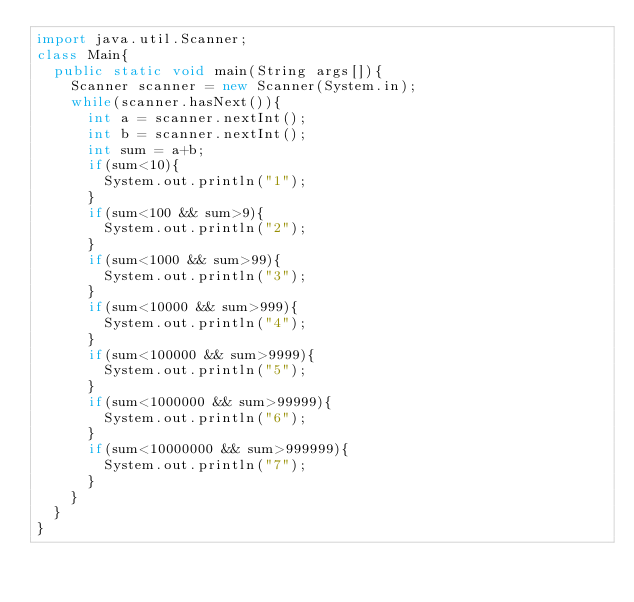Convert code to text. <code><loc_0><loc_0><loc_500><loc_500><_Java_>import java.util.Scanner;
class Main{
	public static void main(String args[]){
		Scanner scanner = new Scanner(System.in);
		while(scanner.hasNext()){	
			int a = scanner.nextInt();
			int b = scanner.nextInt();
			int sum = a+b;
			if(sum<10){
				System.out.println("1");
			}
			if(sum<100 && sum>9){
				System.out.println("2");
			}
			if(sum<1000 && sum>99){
				System.out.println("3");
			}
			if(sum<10000 && sum>999){
				System.out.println("4");
			}
			if(sum<100000 && sum>9999){
				System.out.println("5");
			}
			if(sum<1000000 && sum>99999){
				System.out.println("6");
			}
			if(sum<10000000 && sum>999999){
				System.out.println("7");
			}
		}
	}
}</code> 